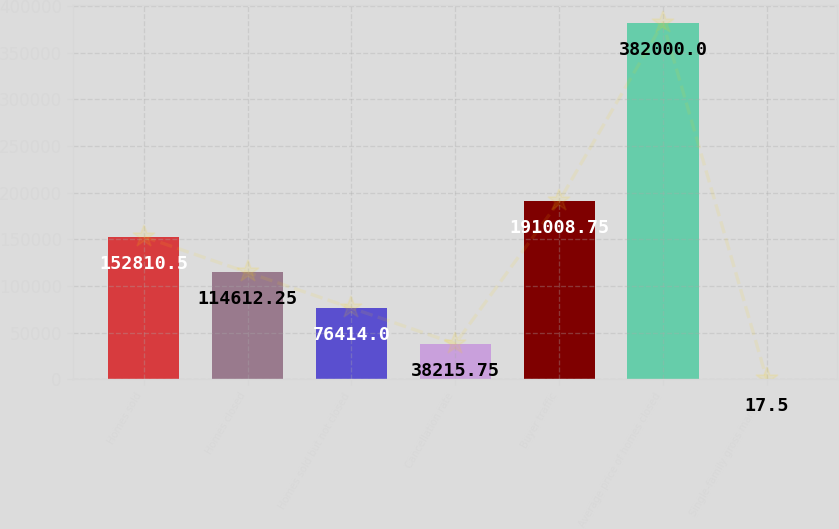<chart> <loc_0><loc_0><loc_500><loc_500><bar_chart><fcel>Homes sold<fcel>Homes closed<fcel>Homes sold but not closed<fcel>Cancellation rate<fcel>Buyer traffic<fcel>Average price of homes closed<fcel>Single-family gross margin -<nl><fcel>152810<fcel>114612<fcel>76414<fcel>38215.8<fcel>191009<fcel>382000<fcel>17.5<nl></chart> 